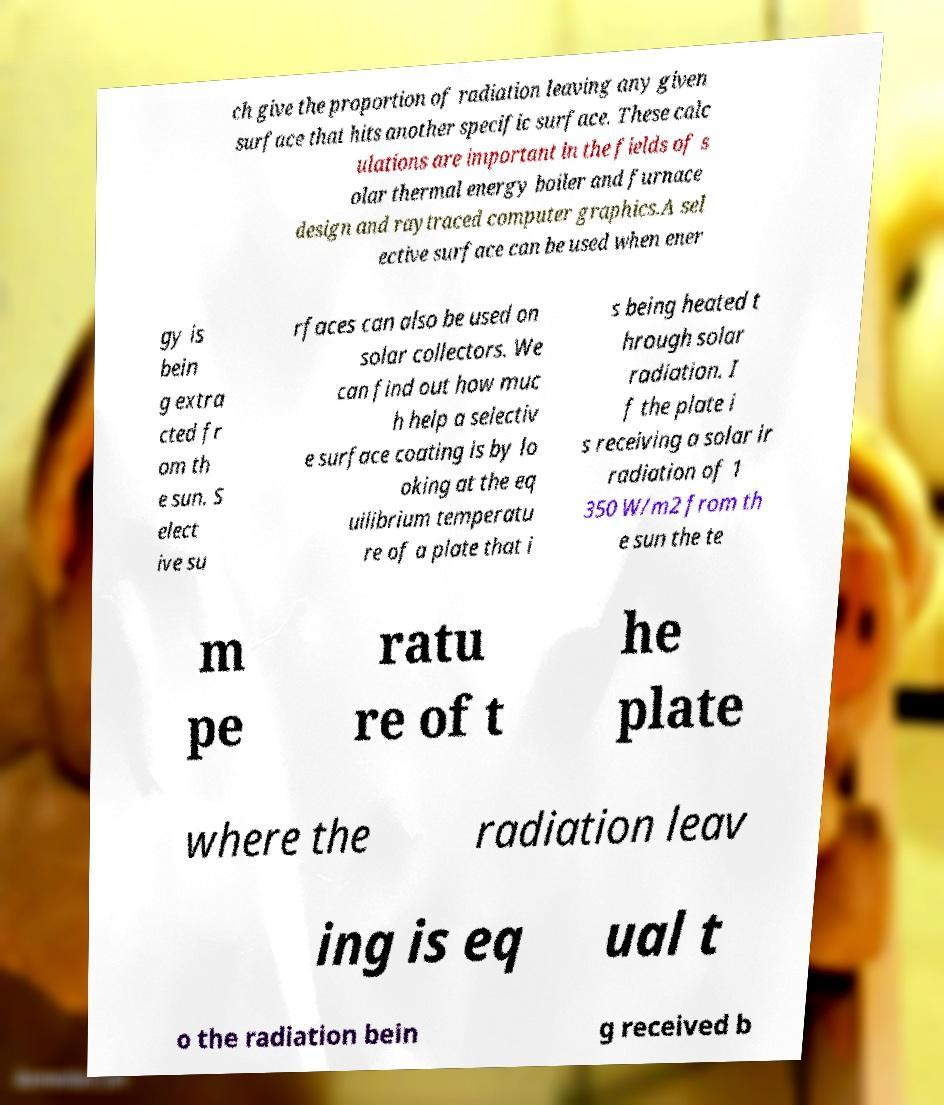Can you accurately transcribe the text from the provided image for me? ch give the proportion of radiation leaving any given surface that hits another specific surface. These calc ulations are important in the fields of s olar thermal energy boiler and furnace design and raytraced computer graphics.A sel ective surface can be used when ener gy is bein g extra cted fr om th e sun. S elect ive su rfaces can also be used on solar collectors. We can find out how muc h help a selectiv e surface coating is by lo oking at the eq uilibrium temperatu re of a plate that i s being heated t hrough solar radiation. I f the plate i s receiving a solar ir radiation of 1 350 W/m2 from th e sun the te m pe ratu re of t he plate where the radiation leav ing is eq ual t o the radiation bein g received b 